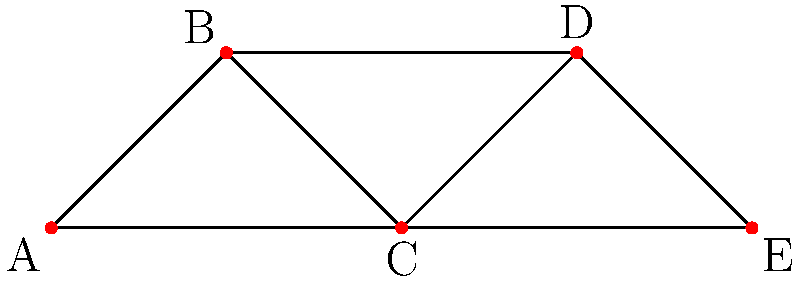In a Swiss football team, players are represented as nodes, and connections between players who frequently pass to each other are represented as edges. Given the network diagram above, which player (node) has the highest degree centrality, and how many direct connections does this player have? To solve this problem, we need to understand the concept of degree centrality in network analysis and count the connections for each node:

1. Degree centrality is a measure of the number of direct connections a node has in a network.
2. Let's count the connections (edges) for each player (node):

   Player A: 2 connections (to B and C)
   Player B: 3 connections (to A, C, and D)
   Player C: 4 connections (to A, B, D, and E)
   Player D: 2 connections (to B and C)
   Player E: 2 connections (to C and D)

3. The player with the highest number of connections is C, with 4 direct connections.

Therefore, player C has the highest degree centrality in this network.
Answer: Player C, 4 connections 